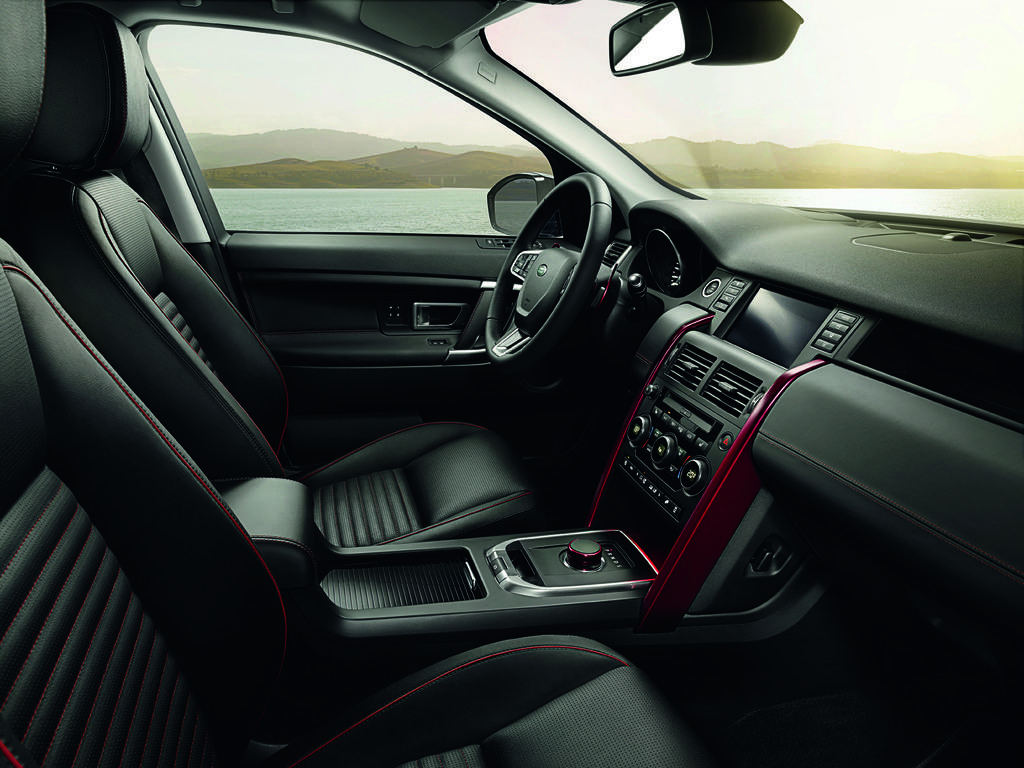What type of setting is depicted in the image? The image shows an interior view of a car. What can be seen inside the car? The car's steering wheel is visible. What is visible outside the car? Mountains and water are visible outside the car. What part of the natural environment can be seen in the image? The sky is visible in the image. Can you tell me how many chess pieces are on the car's dashboard in the image? There are no chess pieces visible on the car's dashboard in the image. What type of border is present between the mountains and the water in the image? There is no border visible between the mountains and the water in the image; it is a continuous natural landscape. 